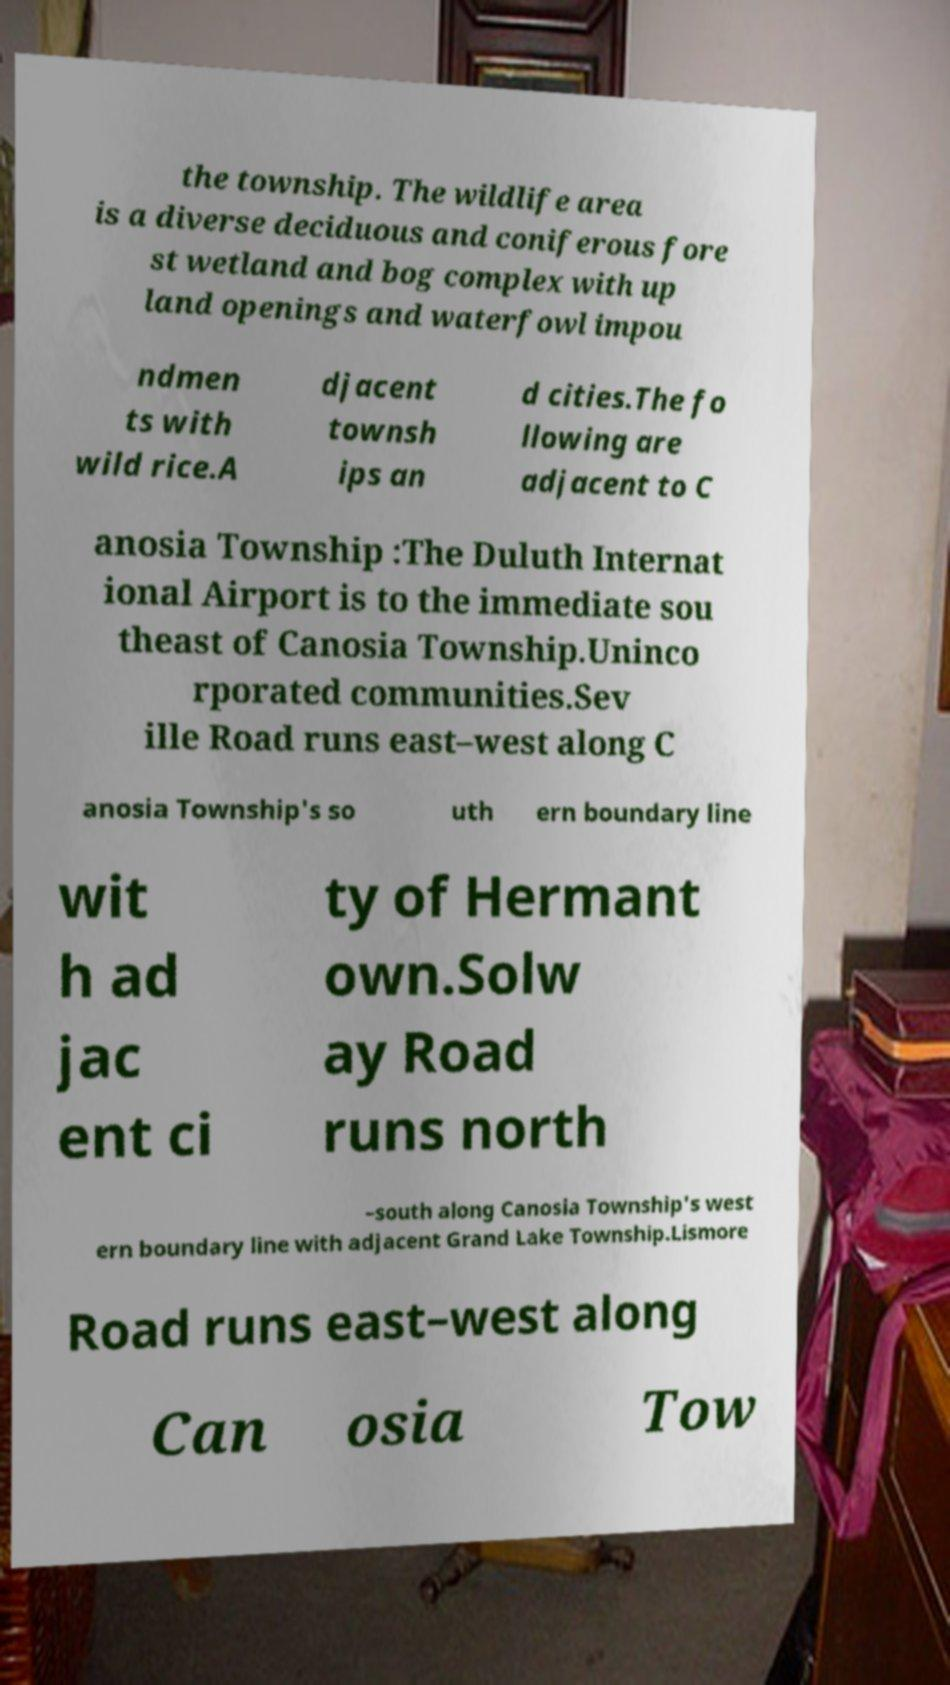Please read and relay the text visible in this image. What does it say? the township. The wildlife area is a diverse deciduous and coniferous fore st wetland and bog complex with up land openings and waterfowl impou ndmen ts with wild rice.A djacent townsh ips an d cities.The fo llowing are adjacent to C anosia Township :The Duluth Internat ional Airport is to the immediate sou theast of Canosia Township.Uninco rporated communities.Sev ille Road runs east–west along C anosia Township's so uth ern boundary line wit h ad jac ent ci ty of Hermant own.Solw ay Road runs north –south along Canosia Township's west ern boundary line with adjacent Grand Lake Township.Lismore Road runs east–west along Can osia Tow 